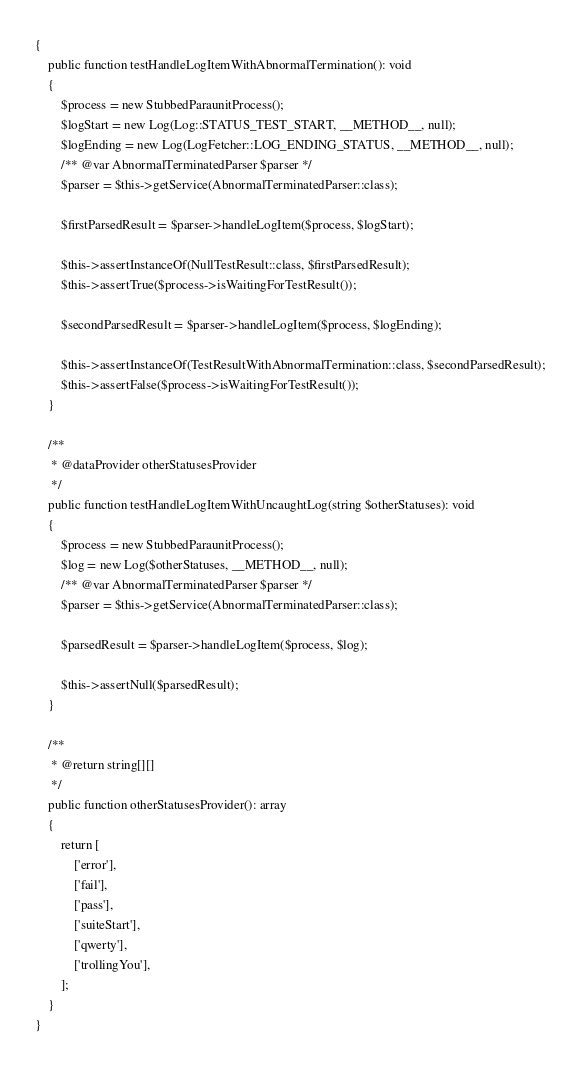<code> <loc_0><loc_0><loc_500><loc_500><_PHP_>{
    public function testHandleLogItemWithAbnormalTermination(): void
    {
        $process = new StubbedParaunitProcess();
        $logStart = new Log(Log::STATUS_TEST_START, __METHOD__, null);
        $logEnding = new Log(LogFetcher::LOG_ENDING_STATUS, __METHOD__, null);
        /** @var AbnormalTerminatedParser $parser */
        $parser = $this->getService(AbnormalTerminatedParser::class);

        $firstParsedResult = $parser->handleLogItem($process, $logStart);

        $this->assertInstanceOf(NullTestResult::class, $firstParsedResult);
        $this->assertTrue($process->isWaitingForTestResult());

        $secondParsedResult = $parser->handleLogItem($process, $logEnding);

        $this->assertInstanceOf(TestResultWithAbnormalTermination::class, $secondParsedResult);
        $this->assertFalse($process->isWaitingForTestResult());
    }

    /**
     * @dataProvider otherStatusesProvider
     */
    public function testHandleLogItemWithUncaughtLog(string $otherStatuses): void
    {
        $process = new StubbedParaunitProcess();
        $log = new Log($otherStatuses, __METHOD__, null);
        /** @var AbnormalTerminatedParser $parser */
        $parser = $this->getService(AbnormalTerminatedParser::class);

        $parsedResult = $parser->handleLogItem($process, $log);

        $this->assertNull($parsedResult);
    }

    /**
     * @return string[][]
     */
    public function otherStatusesProvider(): array
    {
        return [
            ['error'],
            ['fail'],
            ['pass'],
            ['suiteStart'],
            ['qwerty'],
            ['trollingYou'],
        ];
    }
}
</code> 